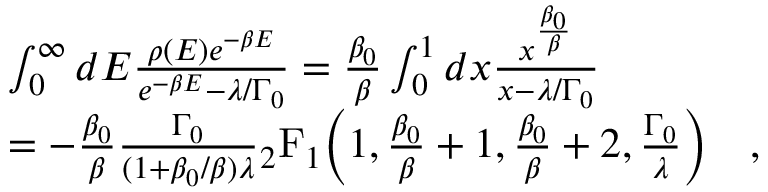Convert formula to latex. <formula><loc_0><loc_0><loc_500><loc_500>\begin{array} { r l } & { \int _ { 0 } ^ { \infty } d E \frac { \rho ( E ) e ^ { - \beta E } } { e ^ { - \beta E } - \lambda / \Gamma _ { 0 } } = \frac { \beta _ { 0 } } { \beta } \int _ { 0 } ^ { 1 } d x \frac { x ^ { \frac { \beta _ { 0 } } { \beta } } } { x - \lambda / \Gamma _ { 0 } } } \\ & { = - \frac { \beta _ { 0 } } { \beta } \frac { \Gamma _ { 0 } } { ( 1 + \beta _ { 0 } / \beta ) \lambda } _ { 2 } F _ { 1 } \left ( 1 , \frac { \beta _ { 0 } } { \beta } + 1 , \frac { \beta _ { 0 } } { \beta } + 2 , \frac { \Gamma _ { 0 } } { \lambda } \right ) \quad , } \end{array}</formula> 